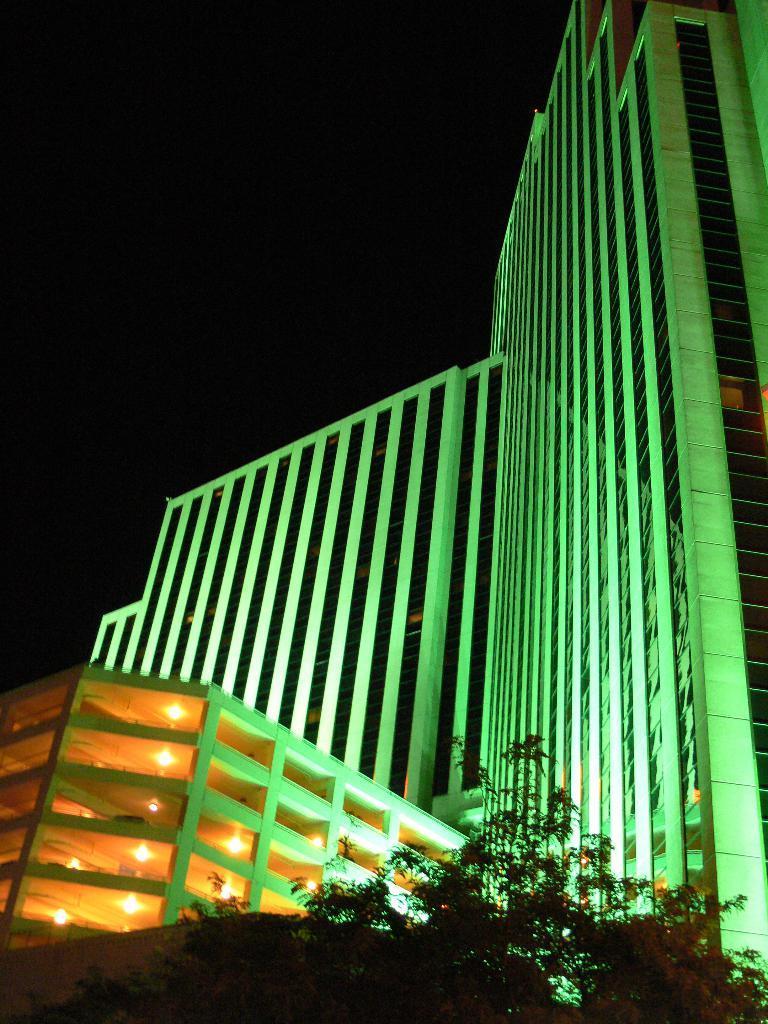Please provide a concise description of this image. In this image we can see building with some lights. At the bottom we can see trees. In the background, we can see the sky. 